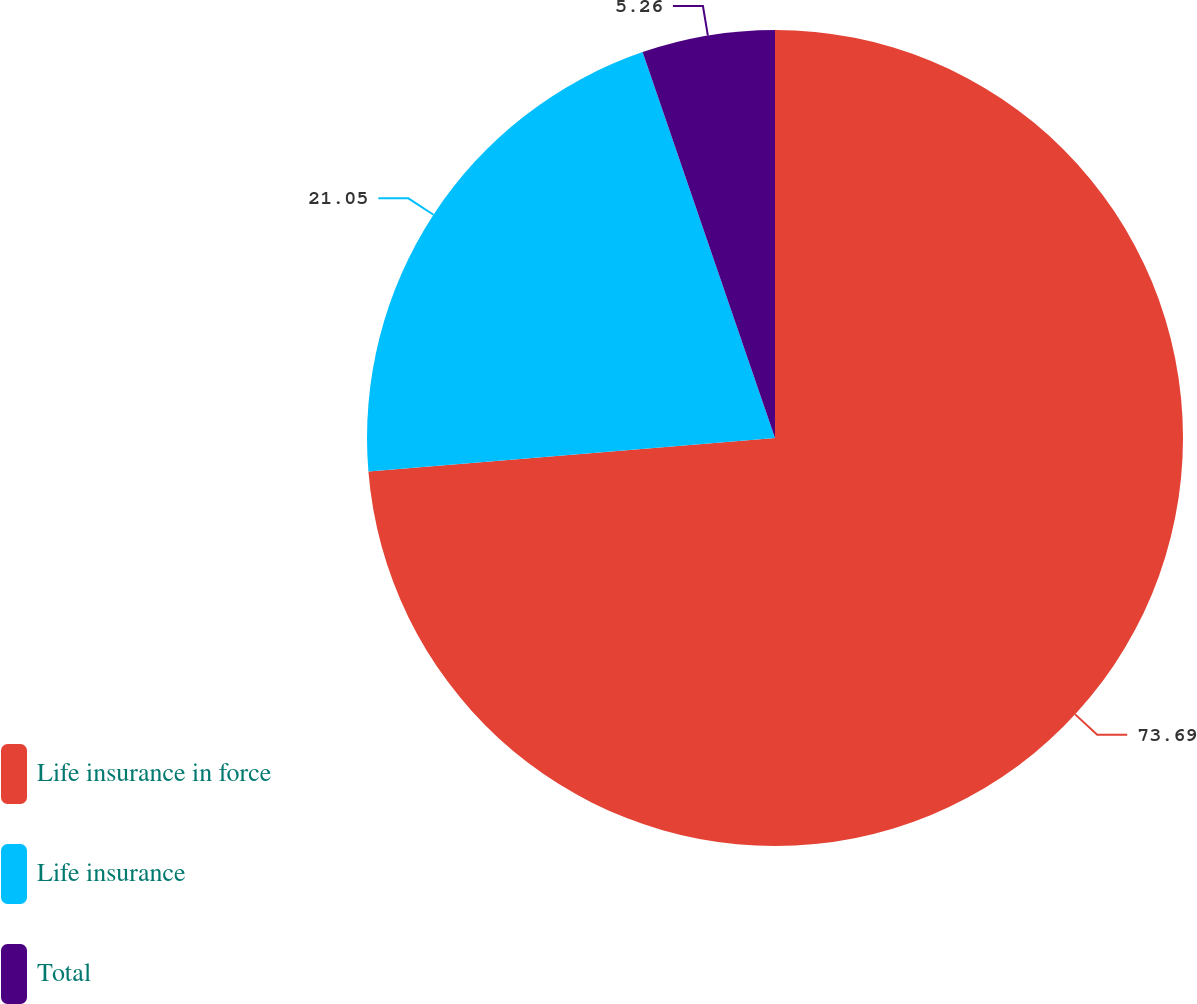Convert chart to OTSL. <chart><loc_0><loc_0><loc_500><loc_500><pie_chart><fcel>Life insurance in force<fcel>Life insurance<fcel>Total<nl><fcel>73.68%<fcel>21.05%<fcel>5.26%<nl></chart> 